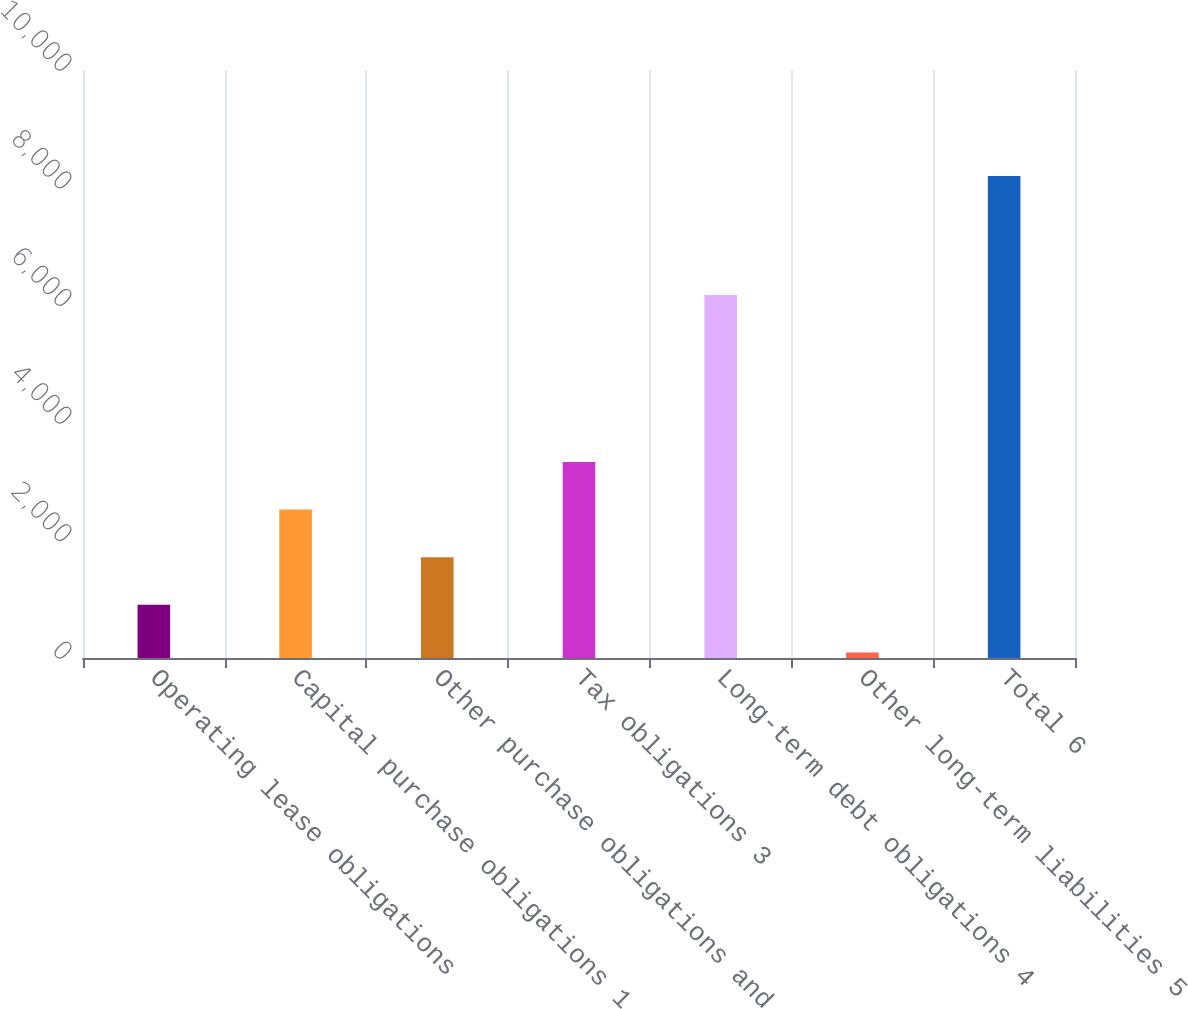<chart> <loc_0><loc_0><loc_500><loc_500><bar_chart><fcel>Operating lease obligations<fcel>Capital purchase obligations 1<fcel>Other purchase obligations and<fcel>Tax obligations 3<fcel>Long-term debt obligations 4<fcel>Other long-term liabilities 5<fcel>Total 6<nl><fcel>905.1<fcel>2525.3<fcel>1715.2<fcel>3335.4<fcel>6173<fcel>95<fcel>8196<nl></chart> 